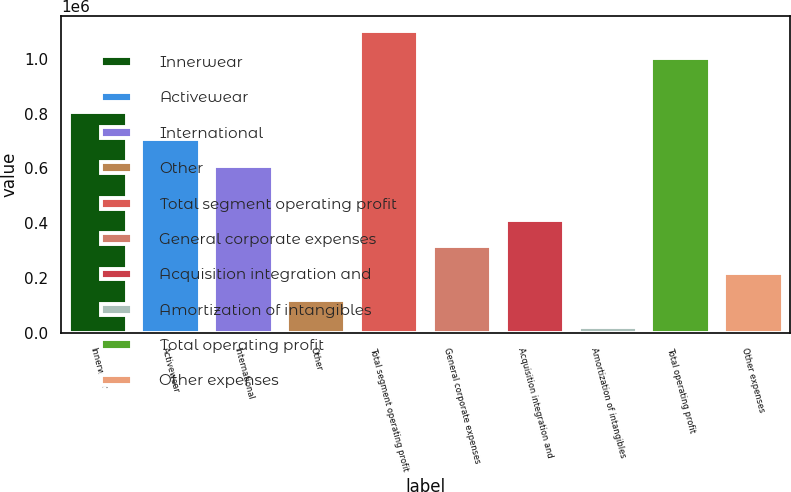<chart> <loc_0><loc_0><loc_500><loc_500><bar_chart><fcel>Innerwear<fcel>Activewear<fcel>International<fcel>Other<fcel>Total segment operating profit<fcel>General corporate expenses<fcel>Acquisition integration and<fcel>Amortization of intangibles<fcel>Total operating profit<fcel>Other expenses<nl><fcel>805448<fcel>707532<fcel>609616<fcel>120034<fcel>1.0992e+06<fcel>315867<fcel>413783<fcel>22118<fcel>1.00128e+06<fcel>217951<nl></chart> 